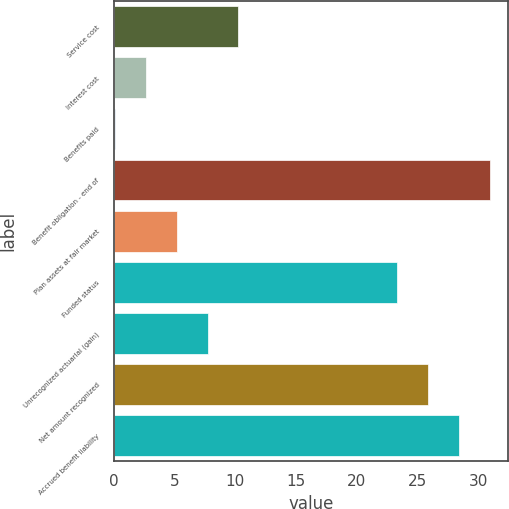Convert chart. <chart><loc_0><loc_0><loc_500><loc_500><bar_chart><fcel>Service cost<fcel>Interest cost<fcel>Benefits paid<fcel>Benefit obligation - end of<fcel>Plan assets at fair market<fcel>Funded status<fcel>Unrecognized actuarial (gain)<fcel>Net amount recognized<fcel>Accrued benefit liability<nl><fcel>10.26<fcel>2.64<fcel>0.1<fcel>30.92<fcel>5.18<fcel>23.3<fcel>7.72<fcel>25.84<fcel>28.38<nl></chart> 